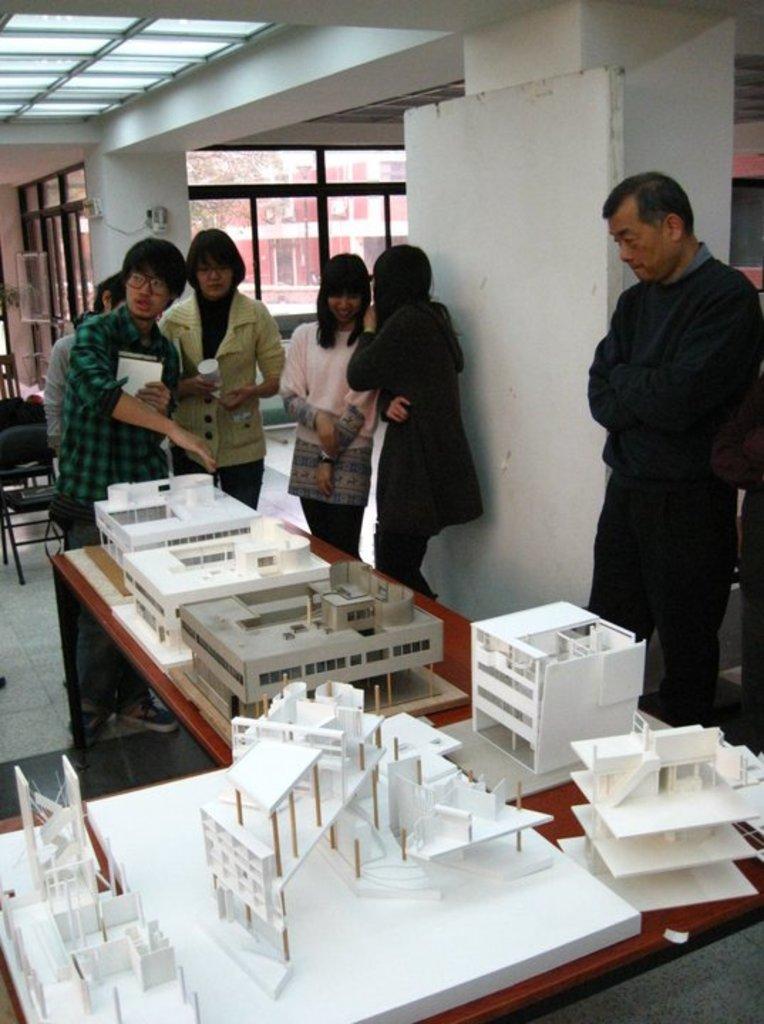Please provide a concise description of this image. In this picture there are a group of people standing here and these two are talking with each other and this person is explaining the examples of the building, the man on the left is listening to him and backdrop there are chairs, ceiling lights and there is a door 